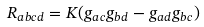<formula> <loc_0><loc_0><loc_500><loc_500>R _ { a b c d } = K ( g _ { a c } g _ { b d } - g _ { a d } g _ { b c } )</formula> 